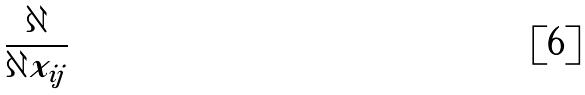<formula> <loc_0><loc_0><loc_500><loc_500>\frac { \partial } { \partial x _ { i j } }</formula> 